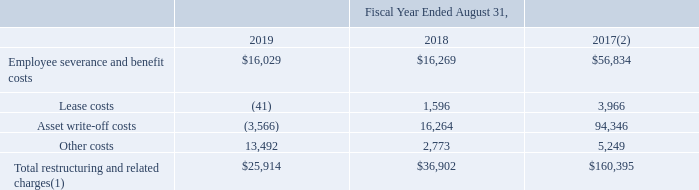14. Restructuring and Related Charges
Following is a summary of the Company’s restructuring and related charges (in thousands):
(1) Includes $21.5 million, $16.3 million and $51.3 million recorded in the EMS segment, $2.6 million, $16.6 million and $82.4 million recorded in the DMS segment and $1.8 million, $4.0 million and $26.7 million of non-allocated charges for the fiscal years ended August 31, 2019, 2018 and 2017, respectively. Except for asset write-off costs, all restructuring and related charges are cash settled.
(2) Fiscal year ended August 31, 2017, includes expenses related to the 2017 and 2013 Restructuring Plans.
What did the amounts in fiscal year ended August 31, 2017 include? Expenses related to the 2017 and 2013 restructuring plans. Which years does the table provide information for the Company’s restructuring and related charges? 2019, 2018, 2017. What were the lease costs in 2019?
Answer scale should be: thousand. (41). What was the change in Employee severance and benefit costs between 2017 and 2018?
Answer scale should be: thousand. 16,269-56,834
Answer: -40565. What was the change in Other costs between 2018 and 2019?
Answer scale should be: thousand. 13,492-2,773
Answer: 10719. What was the percentage change in the Total restructuring and related charges between 2018 and 2019?
Answer scale should be: percent. (25,914-36,902)/36,902
Answer: -29.78. 